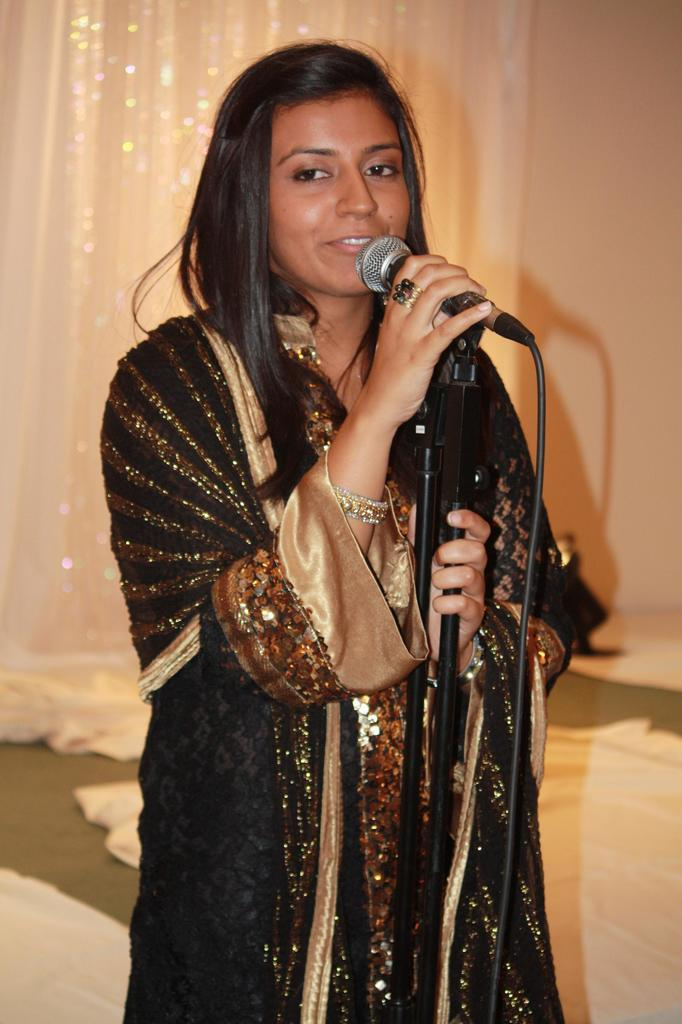What is the woman in the image holding? The woman is holding a mic. What can be seen in the background of the image? There is a wall and a curtain in the background of the image. What else is visible in the background of the image? Clothes are present in the background of the image. How many armchairs are visible in the image? There are no armchairs present in the image. What type of heart-shaped object can be seen in the image? There is no heart-shaped object present in the image. 